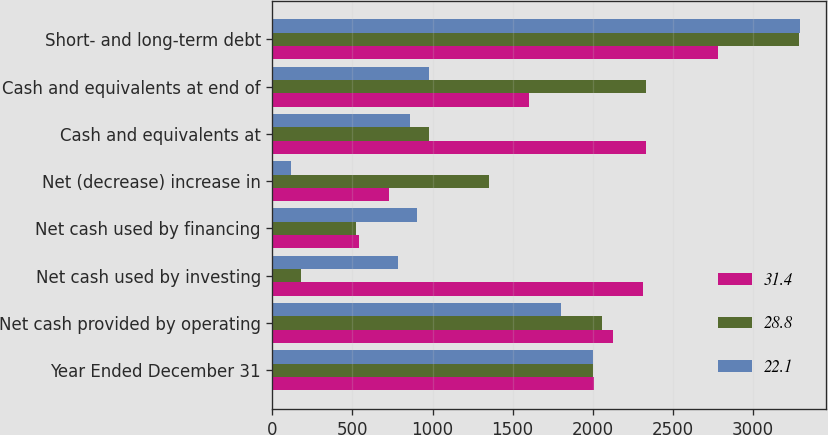<chart> <loc_0><loc_0><loc_500><loc_500><stacked_bar_chart><ecel><fcel>Year Ended December 31<fcel>Net cash provided by operating<fcel>Net cash used by investing<fcel>Net cash used by financing<fcel>Net (decrease) increase in<fcel>Cash and equivalents at<fcel>Cash and equivalents at end of<fcel>Short- and long-term debt<nl><fcel>31.4<fcel>2006<fcel>2128<fcel>2316<fcel>539<fcel>727<fcel>2331<fcel>1604<fcel>2781<nl><fcel>28.8<fcel>2005<fcel>2056<fcel>181<fcel>520<fcel>1355<fcel>976<fcel>2331<fcel>3287<nl><fcel>22.1<fcel>2004<fcel>1803<fcel>786<fcel>902<fcel>115<fcel>861<fcel>976<fcel>3293<nl></chart> 